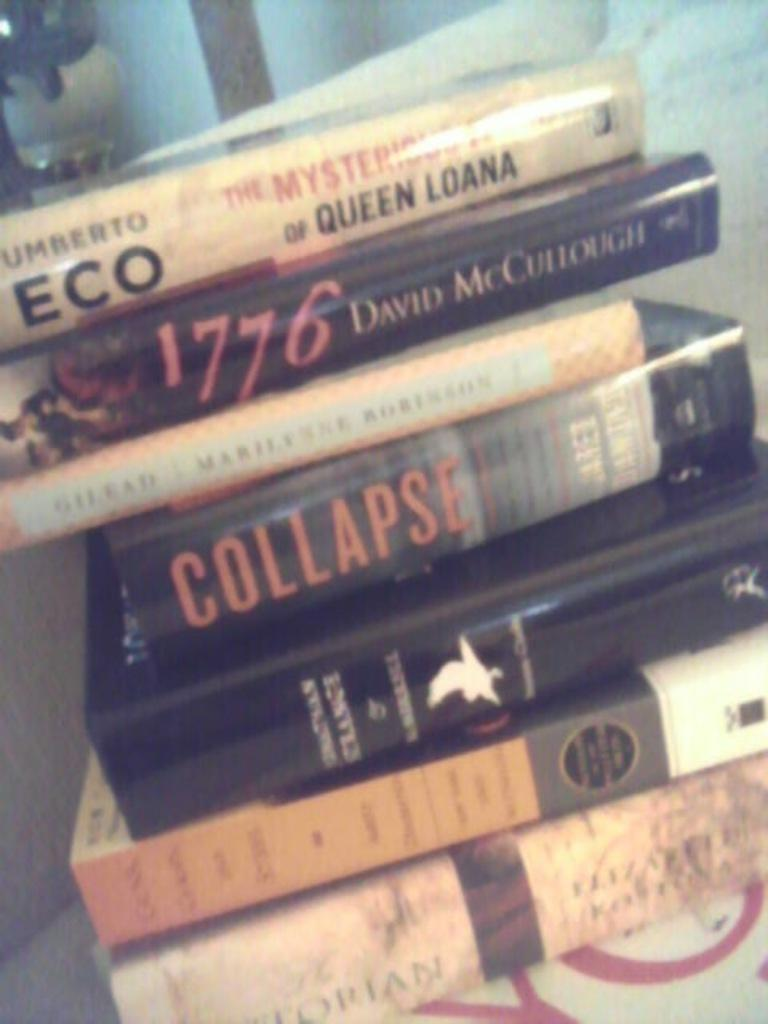<image>
Share a concise interpretation of the image provided. A copy of 1776 by David McCullough is stacked up with some other books. 